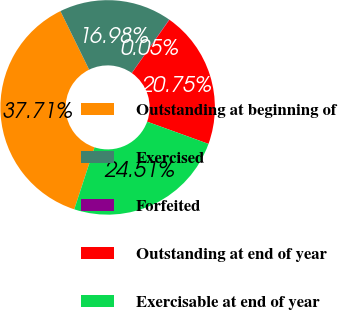Convert chart to OTSL. <chart><loc_0><loc_0><loc_500><loc_500><pie_chart><fcel>Outstanding at beginning of<fcel>Exercised<fcel>Forfeited<fcel>Outstanding at end of year<fcel>Exercisable at end of year<nl><fcel>37.71%<fcel>16.98%<fcel>0.05%<fcel>20.75%<fcel>24.51%<nl></chart> 